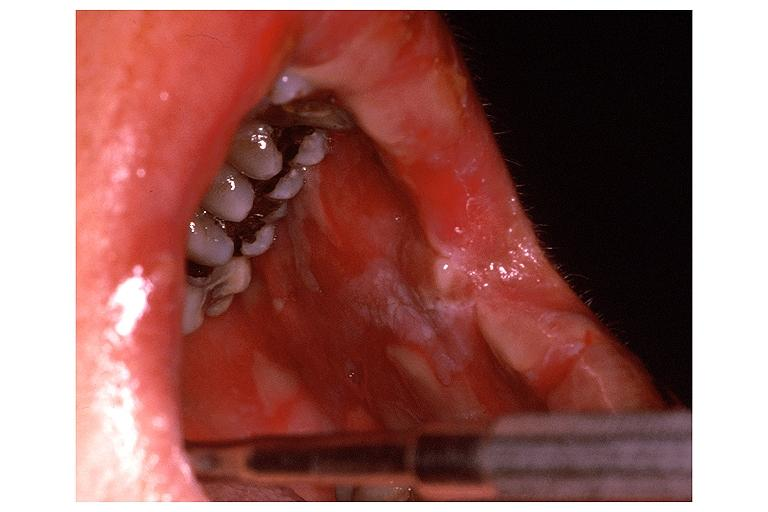where is this?
Answer the question using a single word or phrase. Oral 